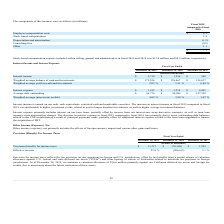According to Formfactor's financial document, How is Interest income earned? on our cash, cash equivalents, restricted cash and marketable securities.. The document states: "Interest income is earned on our cash, cash equivalents, restricted cash and marketable securities. The increase in interest income in fiscal 2019 com..." Also, can you calculate: What is the change in Interest income from Fiscal Year Ended December 28, 2019 to December 29, 2018? Based on the calculation: 2,714-1,356, the result is 1358 (in thousands). This is based on the information: "Interest income $ 2,714 $ 1,356 $ 548 Interest income $ 2,714 $ 1,356 $ 548..." The key data points involved are: 1,356, 2,714. Also, can you calculate: What is the change in Weighted average balance of cash and investments from Fiscal Year Ended December 28, 2019 to December 29, 2018? Based on the calculation: 179,526-138,467, the result is 41059 (in thousands). This is based on the information: "eighted average balance of cash and investments $ 179,526 $ 138,467 $ 124,637 erage balance of cash and investments $ 179,526 $ 138,467 $ 124,637..." The key data points involved are: 138,467, 179,526. Additionally, In which year was Interest income less than 1,000 thousands? According to the financial document, 2017. The relevant text states: "December 28, 2019 December 29, 2018 December 30, 2017..." Also, What was the Weighted average balance of cash and investments in 2019 and 2018 respectively? The document shows two values: $179,526 and $138,467 (in thousands). From the document: "eighted average balance of cash and investments $ 179,526 $ 138,467 $ 124,637 erage balance of cash and investments $ 179,526 $ 138,467 $ 124,637..." Also, What does interest expense include? interest on our term loans, partially offset by income from our interest-rate swap derivative contracts, as well as term loan issuance costs amortization charges.. The document states: "Interest expense primarily includes interest on our term loans, partially offset by income from our interest-rate swap derivative contracts, as well a..." 